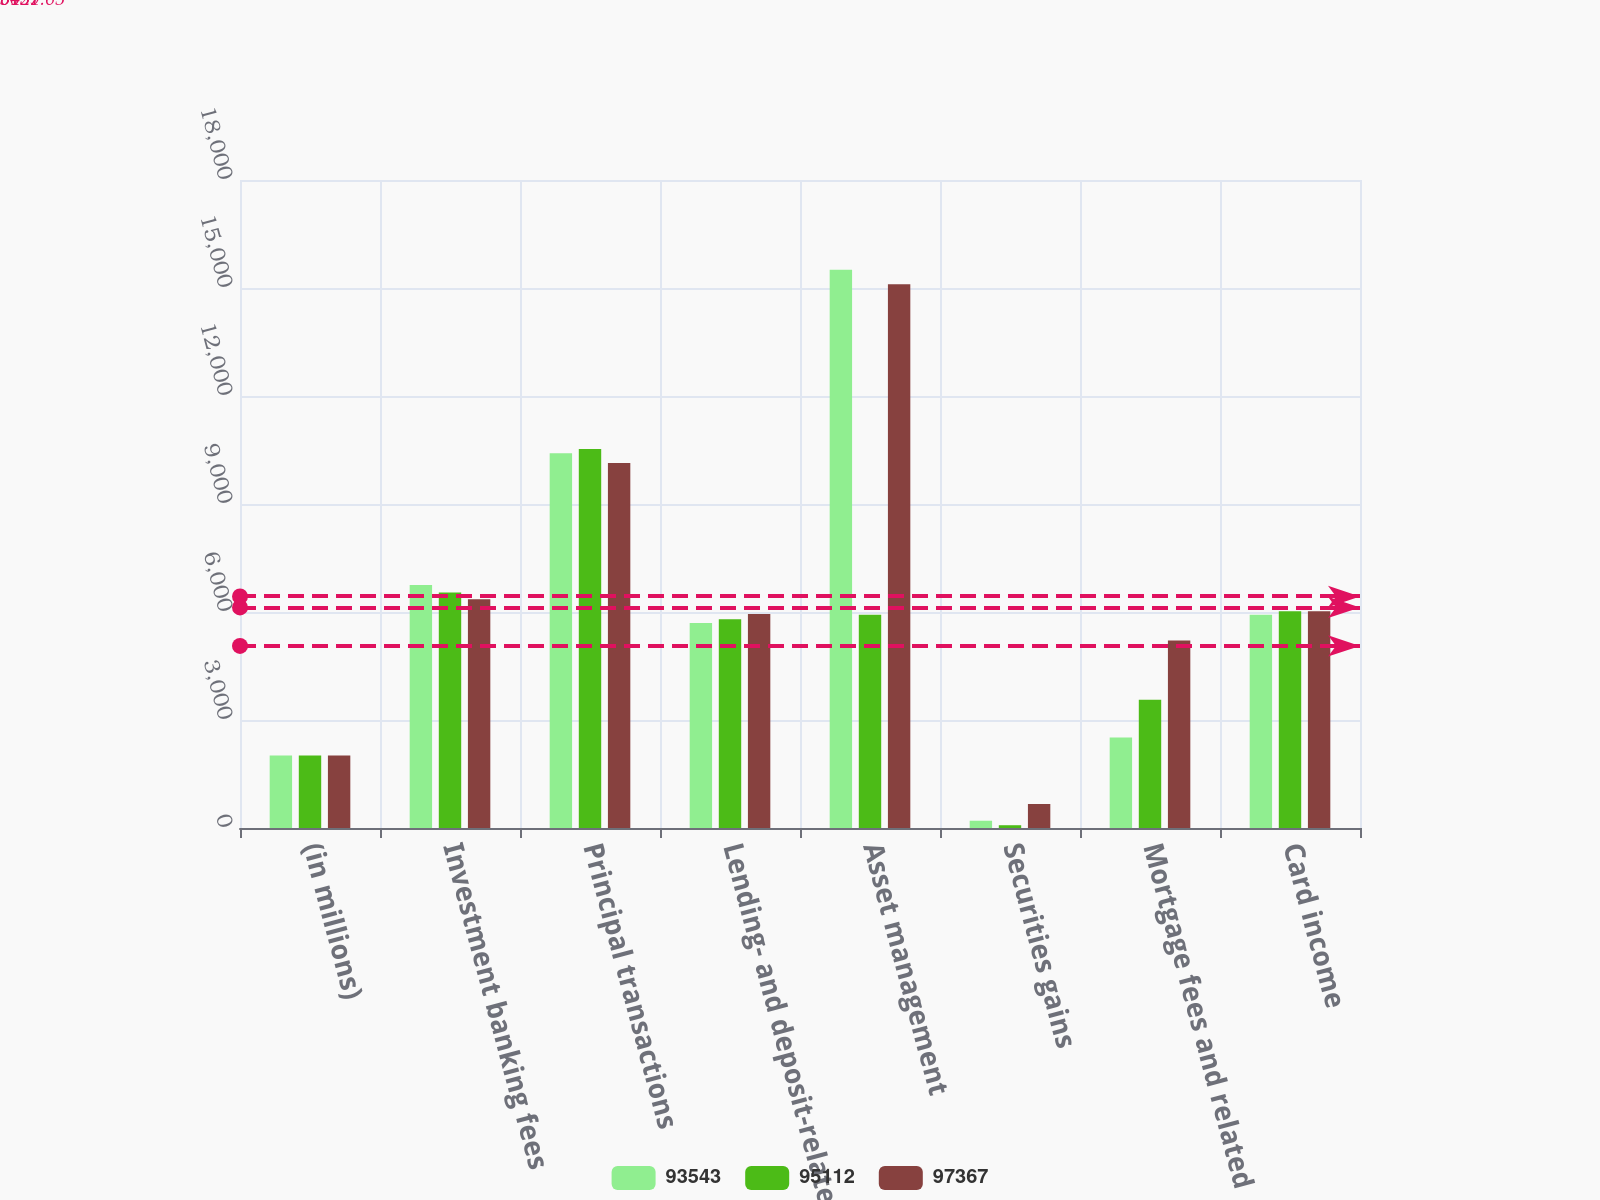<chart> <loc_0><loc_0><loc_500><loc_500><stacked_bar_chart><ecel><fcel>(in millions)<fcel>Investment banking fees<fcel>Principal transactions<fcel>Lending- and deposit-related<fcel>Asset management<fcel>Securities gains<fcel>Mortgage fees and related<fcel>Card income<nl><fcel>93543<fcel>2015<fcel>6751<fcel>10408<fcel>5694<fcel>15509<fcel>202<fcel>2513<fcel>5924<nl><fcel>95112<fcel>2014<fcel>6542<fcel>10531<fcel>5801<fcel>5924<fcel>77<fcel>3563<fcel>6020<nl><fcel>97367<fcel>2013<fcel>6354<fcel>10141<fcel>5945<fcel>15106<fcel>667<fcel>5205<fcel>6022<nl></chart> 